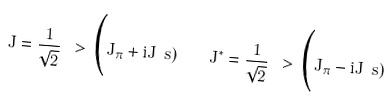Convert formula to latex. <formula><loc_0><loc_0><loc_500><loc_500>J = \frac { 1 } { \sqrt { 2 } } \ > \Big ( J _ { \pi } + i J _ { \ } s ) \quad J ^ { * } = \frac { 1 } { \sqrt { 2 } } \ > \Big ( J _ { \pi } - i J _ { \ } s )</formula> 